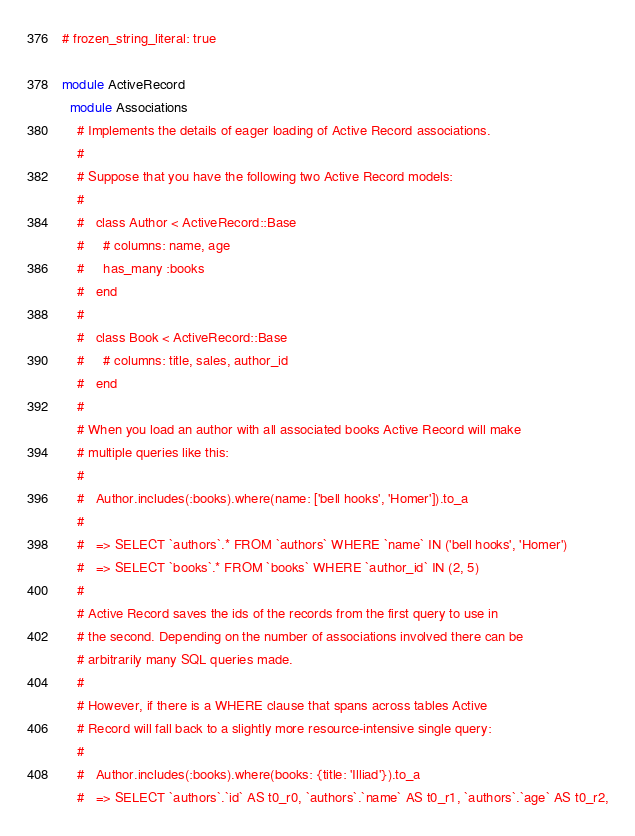Convert code to text. <code><loc_0><loc_0><loc_500><loc_500><_Ruby_># frozen_string_literal: true

module ActiveRecord
  module Associations
    # Implements the details of eager loading of Active Record associations.
    #
    # Suppose that you have the following two Active Record models:
    #
    #   class Author < ActiveRecord::Base
    #     # columns: name, age
    #     has_many :books
    #   end
    #
    #   class Book < ActiveRecord::Base
    #     # columns: title, sales, author_id
    #   end
    #
    # When you load an author with all associated books Active Record will make
    # multiple queries like this:
    #
    #   Author.includes(:books).where(name: ['bell hooks', 'Homer']).to_a
    #
    #   => SELECT `authors`.* FROM `authors` WHERE `name` IN ('bell hooks', 'Homer')
    #   => SELECT `books`.* FROM `books` WHERE `author_id` IN (2, 5)
    #
    # Active Record saves the ids of the records from the first query to use in
    # the second. Depending on the number of associations involved there can be
    # arbitrarily many SQL queries made.
    #
    # However, if there is a WHERE clause that spans across tables Active
    # Record will fall back to a slightly more resource-intensive single query:
    #
    #   Author.includes(:books).where(books: {title: 'Illiad'}).to_a
    #   => SELECT `authors`.`id` AS t0_r0, `authors`.`name` AS t0_r1, `authors`.`age` AS t0_r2,</code> 